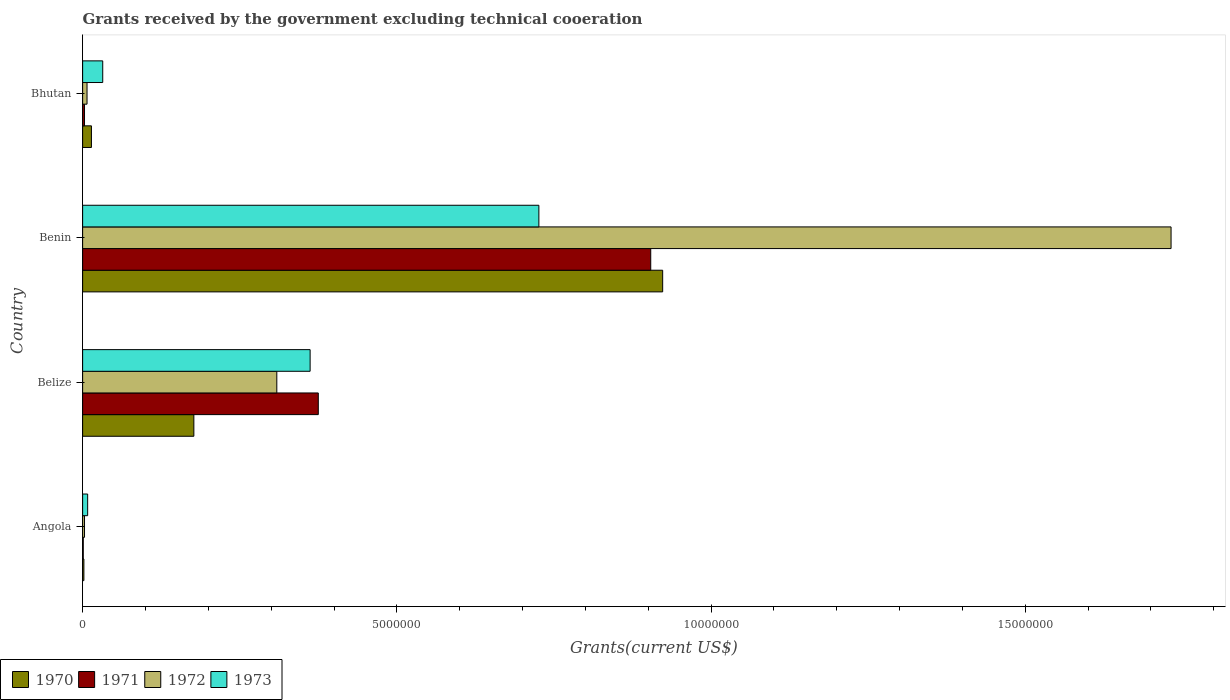How many different coloured bars are there?
Offer a very short reply. 4. How many groups of bars are there?
Make the answer very short. 4. Are the number of bars on each tick of the Y-axis equal?
Make the answer very short. Yes. What is the label of the 1st group of bars from the top?
Your response must be concise. Bhutan. In how many cases, is the number of bars for a given country not equal to the number of legend labels?
Provide a short and direct response. 0. Across all countries, what is the maximum total grants received by the government in 1971?
Offer a very short reply. 9.04e+06. Across all countries, what is the minimum total grants received by the government in 1973?
Make the answer very short. 8.00e+04. In which country was the total grants received by the government in 1971 maximum?
Offer a terse response. Benin. In which country was the total grants received by the government in 1972 minimum?
Your response must be concise. Angola. What is the total total grants received by the government in 1970 in the graph?
Your answer should be compact. 1.12e+07. What is the difference between the total grants received by the government in 1971 in Belize and that in Bhutan?
Provide a short and direct response. 3.72e+06. What is the difference between the total grants received by the government in 1972 in Benin and the total grants received by the government in 1970 in Angola?
Provide a short and direct response. 1.73e+07. What is the average total grants received by the government in 1973 per country?
Your answer should be compact. 2.82e+06. What is the difference between the total grants received by the government in 1973 and total grants received by the government in 1971 in Bhutan?
Your answer should be compact. 2.90e+05. In how many countries, is the total grants received by the government in 1971 greater than 12000000 US$?
Make the answer very short. 0. What is the ratio of the total grants received by the government in 1971 in Angola to that in Belize?
Keep it short and to the point. 0. Is the total grants received by the government in 1972 in Belize less than that in Benin?
Make the answer very short. Yes. What is the difference between the highest and the second highest total grants received by the government in 1972?
Your answer should be compact. 1.42e+07. What is the difference between the highest and the lowest total grants received by the government in 1972?
Give a very brief answer. 1.73e+07. Is the sum of the total grants received by the government in 1973 in Angola and Bhutan greater than the maximum total grants received by the government in 1972 across all countries?
Provide a short and direct response. No. Is it the case that in every country, the sum of the total grants received by the government in 1971 and total grants received by the government in 1972 is greater than the sum of total grants received by the government in 1973 and total grants received by the government in 1970?
Your response must be concise. No. What does the 3rd bar from the top in Belize represents?
Give a very brief answer. 1971. What does the 1st bar from the bottom in Benin represents?
Provide a short and direct response. 1970. How many bars are there?
Provide a short and direct response. 16. Are all the bars in the graph horizontal?
Offer a terse response. Yes. How many countries are there in the graph?
Your response must be concise. 4. Are the values on the major ticks of X-axis written in scientific E-notation?
Ensure brevity in your answer.  No. How many legend labels are there?
Provide a succinct answer. 4. What is the title of the graph?
Your response must be concise. Grants received by the government excluding technical cooeration. Does "2015" appear as one of the legend labels in the graph?
Ensure brevity in your answer.  No. What is the label or title of the X-axis?
Your response must be concise. Grants(current US$). What is the Grants(current US$) of 1970 in Angola?
Your answer should be compact. 2.00e+04. What is the Grants(current US$) of 1971 in Angola?
Your answer should be compact. 10000. What is the Grants(current US$) in 1972 in Angola?
Offer a very short reply. 3.00e+04. What is the Grants(current US$) of 1970 in Belize?
Your answer should be compact. 1.77e+06. What is the Grants(current US$) in 1971 in Belize?
Provide a short and direct response. 3.75e+06. What is the Grants(current US$) of 1972 in Belize?
Your answer should be compact. 3.09e+06. What is the Grants(current US$) in 1973 in Belize?
Make the answer very short. 3.62e+06. What is the Grants(current US$) in 1970 in Benin?
Make the answer very short. 9.23e+06. What is the Grants(current US$) in 1971 in Benin?
Make the answer very short. 9.04e+06. What is the Grants(current US$) in 1972 in Benin?
Provide a short and direct response. 1.73e+07. What is the Grants(current US$) of 1973 in Benin?
Ensure brevity in your answer.  7.26e+06. What is the Grants(current US$) in 1971 in Bhutan?
Give a very brief answer. 3.00e+04. What is the Grants(current US$) of 1972 in Bhutan?
Your answer should be compact. 7.00e+04. Across all countries, what is the maximum Grants(current US$) of 1970?
Offer a very short reply. 9.23e+06. Across all countries, what is the maximum Grants(current US$) in 1971?
Offer a very short reply. 9.04e+06. Across all countries, what is the maximum Grants(current US$) in 1972?
Make the answer very short. 1.73e+07. Across all countries, what is the maximum Grants(current US$) in 1973?
Your response must be concise. 7.26e+06. Across all countries, what is the minimum Grants(current US$) in 1971?
Give a very brief answer. 10000. Across all countries, what is the minimum Grants(current US$) in 1972?
Keep it short and to the point. 3.00e+04. Across all countries, what is the minimum Grants(current US$) of 1973?
Offer a terse response. 8.00e+04. What is the total Grants(current US$) of 1970 in the graph?
Keep it short and to the point. 1.12e+07. What is the total Grants(current US$) of 1971 in the graph?
Provide a succinct answer. 1.28e+07. What is the total Grants(current US$) of 1972 in the graph?
Your answer should be compact. 2.05e+07. What is the total Grants(current US$) in 1973 in the graph?
Ensure brevity in your answer.  1.13e+07. What is the difference between the Grants(current US$) of 1970 in Angola and that in Belize?
Make the answer very short. -1.75e+06. What is the difference between the Grants(current US$) of 1971 in Angola and that in Belize?
Make the answer very short. -3.74e+06. What is the difference between the Grants(current US$) in 1972 in Angola and that in Belize?
Make the answer very short. -3.06e+06. What is the difference between the Grants(current US$) in 1973 in Angola and that in Belize?
Ensure brevity in your answer.  -3.54e+06. What is the difference between the Grants(current US$) in 1970 in Angola and that in Benin?
Give a very brief answer. -9.21e+06. What is the difference between the Grants(current US$) of 1971 in Angola and that in Benin?
Provide a succinct answer. -9.03e+06. What is the difference between the Grants(current US$) in 1972 in Angola and that in Benin?
Offer a terse response. -1.73e+07. What is the difference between the Grants(current US$) in 1973 in Angola and that in Benin?
Your answer should be very brief. -7.18e+06. What is the difference between the Grants(current US$) of 1973 in Angola and that in Bhutan?
Keep it short and to the point. -2.40e+05. What is the difference between the Grants(current US$) of 1970 in Belize and that in Benin?
Give a very brief answer. -7.46e+06. What is the difference between the Grants(current US$) of 1971 in Belize and that in Benin?
Keep it short and to the point. -5.29e+06. What is the difference between the Grants(current US$) in 1972 in Belize and that in Benin?
Make the answer very short. -1.42e+07. What is the difference between the Grants(current US$) of 1973 in Belize and that in Benin?
Offer a terse response. -3.64e+06. What is the difference between the Grants(current US$) of 1970 in Belize and that in Bhutan?
Provide a succinct answer. 1.63e+06. What is the difference between the Grants(current US$) of 1971 in Belize and that in Bhutan?
Keep it short and to the point. 3.72e+06. What is the difference between the Grants(current US$) of 1972 in Belize and that in Bhutan?
Give a very brief answer. 3.02e+06. What is the difference between the Grants(current US$) of 1973 in Belize and that in Bhutan?
Keep it short and to the point. 3.30e+06. What is the difference between the Grants(current US$) of 1970 in Benin and that in Bhutan?
Offer a very short reply. 9.09e+06. What is the difference between the Grants(current US$) of 1971 in Benin and that in Bhutan?
Keep it short and to the point. 9.01e+06. What is the difference between the Grants(current US$) in 1972 in Benin and that in Bhutan?
Keep it short and to the point. 1.72e+07. What is the difference between the Grants(current US$) in 1973 in Benin and that in Bhutan?
Make the answer very short. 6.94e+06. What is the difference between the Grants(current US$) in 1970 in Angola and the Grants(current US$) in 1971 in Belize?
Offer a very short reply. -3.73e+06. What is the difference between the Grants(current US$) of 1970 in Angola and the Grants(current US$) of 1972 in Belize?
Provide a succinct answer. -3.07e+06. What is the difference between the Grants(current US$) of 1970 in Angola and the Grants(current US$) of 1973 in Belize?
Offer a very short reply. -3.60e+06. What is the difference between the Grants(current US$) of 1971 in Angola and the Grants(current US$) of 1972 in Belize?
Ensure brevity in your answer.  -3.08e+06. What is the difference between the Grants(current US$) of 1971 in Angola and the Grants(current US$) of 1973 in Belize?
Your response must be concise. -3.61e+06. What is the difference between the Grants(current US$) in 1972 in Angola and the Grants(current US$) in 1973 in Belize?
Your answer should be compact. -3.59e+06. What is the difference between the Grants(current US$) in 1970 in Angola and the Grants(current US$) in 1971 in Benin?
Make the answer very short. -9.02e+06. What is the difference between the Grants(current US$) in 1970 in Angola and the Grants(current US$) in 1972 in Benin?
Your answer should be compact. -1.73e+07. What is the difference between the Grants(current US$) of 1970 in Angola and the Grants(current US$) of 1973 in Benin?
Your answer should be compact. -7.24e+06. What is the difference between the Grants(current US$) in 1971 in Angola and the Grants(current US$) in 1972 in Benin?
Make the answer very short. -1.73e+07. What is the difference between the Grants(current US$) of 1971 in Angola and the Grants(current US$) of 1973 in Benin?
Provide a short and direct response. -7.25e+06. What is the difference between the Grants(current US$) of 1972 in Angola and the Grants(current US$) of 1973 in Benin?
Make the answer very short. -7.23e+06. What is the difference between the Grants(current US$) in 1970 in Angola and the Grants(current US$) in 1971 in Bhutan?
Provide a short and direct response. -10000. What is the difference between the Grants(current US$) of 1970 in Angola and the Grants(current US$) of 1973 in Bhutan?
Offer a terse response. -3.00e+05. What is the difference between the Grants(current US$) in 1971 in Angola and the Grants(current US$) in 1972 in Bhutan?
Provide a short and direct response. -6.00e+04. What is the difference between the Grants(current US$) in 1971 in Angola and the Grants(current US$) in 1973 in Bhutan?
Ensure brevity in your answer.  -3.10e+05. What is the difference between the Grants(current US$) in 1970 in Belize and the Grants(current US$) in 1971 in Benin?
Your answer should be compact. -7.27e+06. What is the difference between the Grants(current US$) in 1970 in Belize and the Grants(current US$) in 1972 in Benin?
Give a very brief answer. -1.56e+07. What is the difference between the Grants(current US$) in 1970 in Belize and the Grants(current US$) in 1973 in Benin?
Keep it short and to the point. -5.49e+06. What is the difference between the Grants(current US$) of 1971 in Belize and the Grants(current US$) of 1972 in Benin?
Ensure brevity in your answer.  -1.36e+07. What is the difference between the Grants(current US$) in 1971 in Belize and the Grants(current US$) in 1973 in Benin?
Give a very brief answer. -3.51e+06. What is the difference between the Grants(current US$) of 1972 in Belize and the Grants(current US$) of 1973 in Benin?
Provide a short and direct response. -4.17e+06. What is the difference between the Grants(current US$) of 1970 in Belize and the Grants(current US$) of 1971 in Bhutan?
Your answer should be very brief. 1.74e+06. What is the difference between the Grants(current US$) in 1970 in Belize and the Grants(current US$) in 1972 in Bhutan?
Your answer should be very brief. 1.70e+06. What is the difference between the Grants(current US$) of 1970 in Belize and the Grants(current US$) of 1973 in Bhutan?
Provide a succinct answer. 1.45e+06. What is the difference between the Grants(current US$) of 1971 in Belize and the Grants(current US$) of 1972 in Bhutan?
Ensure brevity in your answer.  3.68e+06. What is the difference between the Grants(current US$) in 1971 in Belize and the Grants(current US$) in 1973 in Bhutan?
Your answer should be very brief. 3.43e+06. What is the difference between the Grants(current US$) of 1972 in Belize and the Grants(current US$) of 1973 in Bhutan?
Your answer should be very brief. 2.77e+06. What is the difference between the Grants(current US$) of 1970 in Benin and the Grants(current US$) of 1971 in Bhutan?
Offer a terse response. 9.20e+06. What is the difference between the Grants(current US$) in 1970 in Benin and the Grants(current US$) in 1972 in Bhutan?
Keep it short and to the point. 9.16e+06. What is the difference between the Grants(current US$) in 1970 in Benin and the Grants(current US$) in 1973 in Bhutan?
Make the answer very short. 8.91e+06. What is the difference between the Grants(current US$) in 1971 in Benin and the Grants(current US$) in 1972 in Bhutan?
Provide a succinct answer. 8.97e+06. What is the difference between the Grants(current US$) in 1971 in Benin and the Grants(current US$) in 1973 in Bhutan?
Provide a short and direct response. 8.72e+06. What is the difference between the Grants(current US$) in 1972 in Benin and the Grants(current US$) in 1973 in Bhutan?
Offer a terse response. 1.70e+07. What is the average Grants(current US$) in 1970 per country?
Give a very brief answer. 2.79e+06. What is the average Grants(current US$) in 1971 per country?
Your response must be concise. 3.21e+06. What is the average Grants(current US$) of 1972 per country?
Ensure brevity in your answer.  5.13e+06. What is the average Grants(current US$) in 1973 per country?
Provide a succinct answer. 2.82e+06. What is the difference between the Grants(current US$) in 1970 and Grants(current US$) in 1971 in Angola?
Offer a very short reply. 10000. What is the difference between the Grants(current US$) of 1970 and Grants(current US$) of 1972 in Angola?
Your response must be concise. -10000. What is the difference between the Grants(current US$) in 1970 and Grants(current US$) in 1973 in Angola?
Provide a succinct answer. -6.00e+04. What is the difference between the Grants(current US$) of 1972 and Grants(current US$) of 1973 in Angola?
Provide a short and direct response. -5.00e+04. What is the difference between the Grants(current US$) of 1970 and Grants(current US$) of 1971 in Belize?
Give a very brief answer. -1.98e+06. What is the difference between the Grants(current US$) of 1970 and Grants(current US$) of 1972 in Belize?
Your response must be concise. -1.32e+06. What is the difference between the Grants(current US$) in 1970 and Grants(current US$) in 1973 in Belize?
Your answer should be compact. -1.85e+06. What is the difference between the Grants(current US$) in 1971 and Grants(current US$) in 1973 in Belize?
Provide a succinct answer. 1.30e+05. What is the difference between the Grants(current US$) in 1972 and Grants(current US$) in 1973 in Belize?
Ensure brevity in your answer.  -5.30e+05. What is the difference between the Grants(current US$) in 1970 and Grants(current US$) in 1972 in Benin?
Make the answer very short. -8.09e+06. What is the difference between the Grants(current US$) of 1970 and Grants(current US$) of 1973 in Benin?
Provide a succinct answer. 1.97e+06. What is the difference between the Grants(current US$) of 1971 and Grants(current US$) of 1972 in Benin?
Your answer should be compact. -8.28e+06. What is the difference between the Grants(current US$) in 1971 and Grants(current US$) in 1973 in Benin?
Your answer should be compact. 1.78e+06. What is the difference between the Grants(current US$) in 1972 and Grants(current US$) in 1973 in Benin?
Your response must be concise. 1.01e+07. What is the difference between the Grants(current US$) of 1970 and Grants(current US$) of 1972 in Bhutan?
Make the answer very short. 7.00e+04. What is the difference between the Grants(current US$) of 1970 and Grants(current US$) of 1973 in Bhutan?
Keep it short and to the point. -1.80e+05. What is the difference between the Grants(current US$) of 1971 and Grants(current US$) of 1973 in Bhutan?
Give a very brief answer. -2.90e+05. What is the ratio of the Grants(current US$) in 1970 in Angola to that in Belize?
Provide a short and direct response. 0.01. What is the ratio of the Grants(current US$) in 1971 in Angola to that in Belize?
Ensure brevity in your answer.  0. What is the ratio of the Grants(current US$) of 1972 in Angola to that in Belize?
Make the answer very short. 0.01. What is the ratio of the Grants(current US$) of 1973 in Angola to that in Belize?
Give a very brief answer. 0.02. What is the ratio of the Grants(current US$) in 1970 in Angola to that in Benin?
Provide a short and direct response. 0. What is the ratio of the Grants(current US$) of 1971 in Angola to that in Benin?
Your answer should be compact. 0. What is the ratio of the Grants(current US$) of 1972 in Angola to that in Benin?
Provide a short and direct response. 0. What is the ratio of the Grants(current US$) of 1973 in Angola to that in Benin?
Make the answer very short. 0.01. What is the ratio of the Grants(current US$) of 1970 in Angola to that in Bhutan?
Provide a short and direct response. 0.14. What is the ratio of the Grants(current US$) of 1972 in Angola to that in Bhutan?
Keep it short and to the point. 0.43. What is the ratio of the Grants(current US$) in 1970 in Belize to that in Benin?
Provide a succinct answer. 0.19. What is the ratio of the Grants(current US$) in 1971 in Belize to that in Benin?
Keep it short and to the point. 0.41. What is the ratio of the Grants(current US$) of 1972 in Belize to that in Benin?
Ensure brevity in your answer.  0.18. What is the ratio of the Grants(current US$) of 1973 in Belize to that in Benin?
Offer a very short reply. 0.5. What is the ratio of the Grants(current US$) in 1970 in Belize to that in Bhutan?
Your answer should be compact. 12.64. What is the ratio of the Grants(current US$) in 1971 in Belize to that in Bhutan?
Ensure brevity in your answer.  125. What is the ratio of the Grants(current US$) of 1972 in Belize to that in Bhutan?
Offer a terse response. 44.14. What is the ratio of the Grants(current US$) in 1973 in Belize to that in Bhutan?
Provide a short and direct response. 11.31. What is the ratio of the Grants(current US$) in 1970 in Benin to that in Bhutan?
Keep it short and to the point. 65.93. What is the ratio of the Grants(current US$) of 1971 in Benin to that in Bhutan?
Ensure brevity in your answer.  301.33. What is the ratio of the Grants(current US$) in 1972 in Benin to that in Bhutan?
Offer a very short reply. 247.43. What is the ratio of the Grants(current US$) of 1973 in Benin to that in Bhutan?
Ensure brevity in your answer.  22.69. What is the difference between the highest and the second highest Grants(current US$) in 1970?
Offer a very short reply. 7.46e+06. What is the difference between the highest and the second highest Grants(current US$) of 1971?
Your answer should be very brief. 5.29e+06. What is the difference between the highest and the second highest Grants(current US$) of 1972?
Your answer should be very brief. 1.42e+07. What is the difference between the highest and the second highest Grants(current US$) of 1973?
Give a very brief answer. 3.64e+06. What is the difference between the highest and the lowest Grants(current US$) in 1970?
Your response must be concise. 9.21e+06. What is the difference between the highest and the lowest Grants(current US$) of 1971?
Offer a very short reply. 9.03e+06. What is the difference between the highest and the lowest Grants(current US$) of 1972?
Your response must be concise. 1.73e+07. What is the difference between the highest and the lowest Grants(current US$) of 1973?
Provide a short and direct response. 7.18e+06. 